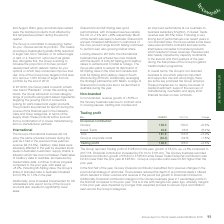According to Premier Foods Plc's financial document, How much was the growth in trading profit in the year 2018/19? According to the financial document, growth of £5.5m. The relevant text states: "p reported Trading profit of £128.5m in the year, growth of £5.5m, up +4.5% compared to 2017/18. Divisional contribution increased by £6.1m to £161.9m. The Grocery b..." Also, What is the divisional contribution of grocery in 2018/19? According to the financial document, 138.3 (in millions). The relevant text states: "Grocery 138.3 130.0 +6.3% Sweet Treats 23.6 25.8 (8.4%) Total 161.9 155.8 +3.9% Group & corporate costs (33.4) (3..." Also, What is the divisional contribution of grocery in 2017/18? According to the financial document, 130.0 (in millions). The relevant text states: "Grocery 138.3 130.0 +6.3% Sweet Treats 23.6 25.8 (8.4%) Total 161.9 155.8 +3.9% Group & corporate costs (33.4) (32.8) (..." Also, can you calculate: What is the change in Divisional contribution of Grocery from 2018/19 to 2017/18? Based on the calculation: 138.3-130.0, the result is 8.3 (in millions). This is based on the information: "Grocery 138.3 130.0 +6.3% Sweet Treats 23.6 25.8 (8.4%) Total 161.9 155.8 +3.9% Group & corporate costs (33.4) (32.8) ( Grocery 138.3 130.0 +6.3% Sweet Treats 23.6 25.8 (8.4%) Total 161.9 155.8 +3.9% ..." The key data points involved are: 130.0, 138.3. Also, can you calculate: What is the change in Divisional contribution of Sweet Treats from 2018/19 to 2017/18? Based on the calculation: 23.6-25.8, the result is -2.2 (in millions). This is based on the information: "Grocery 138.3 130.0 +6.3% Sweet Treats 23.6 25.8 (8.4%) Total 161.9 155.8 +3.9% Group & corporate costs (33.4) (32.8) (1.8%) Grocery 138.3 130.0 +6.3% Sweet Treats 23.6 25.8 (8.4%) Total 161.9 155.8 +..." The key data points involved are: 23.6, 25.8. Also, can you calculate: What is the change in Group & corporate costs from 2018/19 to 2017/18? Based on the calculation: 33.4-32.8, the result is 0.6 (in millions). This is based on the information: "Total 161.9 155.8 +3.9% Group & corporate costs (33.4) (32.8) (1.8%) 161.9 155.8 +3.9% Group & corporate costs (33.4) (32.8) (1.8%)..." The key data points involved are: 32.8, 33.4. 